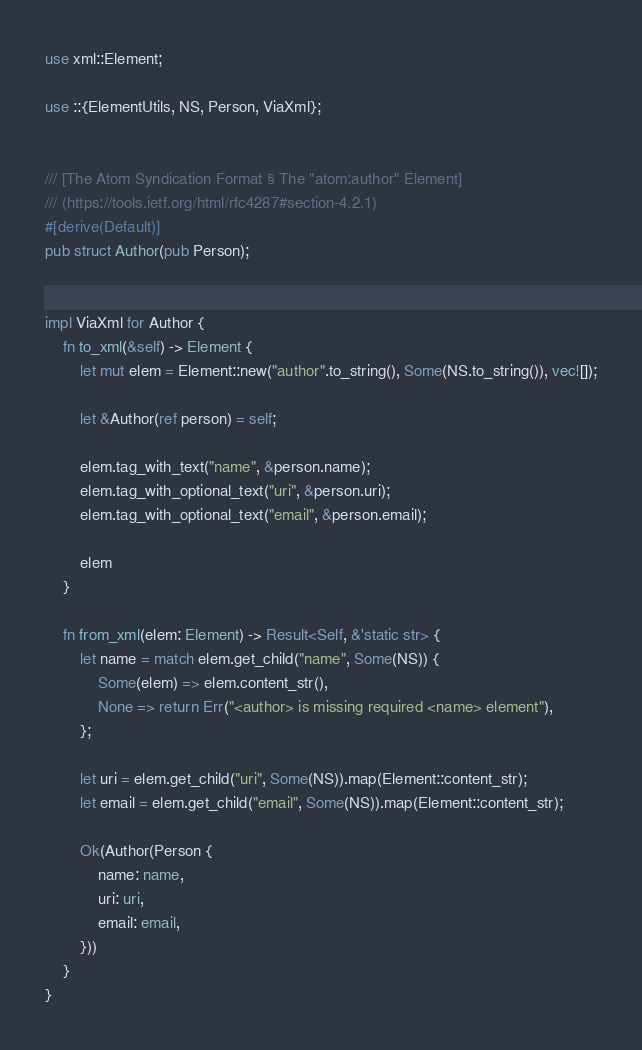Convert code to text. <code><loc_0><loc_0><loc_500><loc_500><_Rust_>use xml::Element;

use ::{ElementUtils, NS, Person, ViaXml};


/// [The Atom Syndication Format § The "atom:author" Element]
/// (https://tools.ietf.org/html/rfc4287#section-4.2.1)
#[derive(Default)]
pub struct Author(pub Person);


impl ViaXml for Author {
    fn to_xml(&self) -> Element {
        let mut elem = Element::new("author".to_string(), Some(NS.to_string()), vec![]);

        let &Author(ref person) = self;

        elem.tag_with_text("name", &person.name);
        elem.tag_with_optional_text("uri", &person.uri);
        elem.tag_with_optional_text("email", &person.email);

        elem
    }

    fn from_xml(elem: Element) -> Result<Self, &'static str> {
        let name = match elem.get_child("name", Some(NS)) {
            Some(elem) => elem.content_str(),
            None => return Err("<author> is missing required <name> element"),
        };

        let uri = elem.get_child("uri", Some(NS)).map(Element::content_str);
        let email = elem.get_child("email", Some(NS)).map(Element::content_str);

        Ok(Author(Person {
            name: name,
            uri: uri,
            email: email,
        }))
    }
}
</code> 